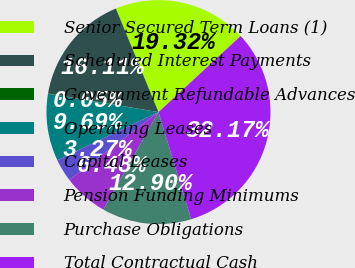Convert chart to OTSL. <chart><loc_0><loc_0><loc_500><loc_500><pie_chart><fcel>Senior Secured Term Loans (1)<fcel>Scheduled Interest Payments<fcel>Government Refundable Advances<fcel>Operating Leases<fcel>Capital Leases<fcel>Pension Funding Minimums<fcel>Purchase Obligations<fcel>Total Contractual Cash<nl><fcel>19.32%<fcel>16.11%<fcel>0.05%<fcel>9.69%<fcel>3.27%<fcel>6.48%<fcel>12.9%<fcel>32.17%<nl></chart> 